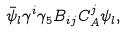<formula> <loc_0><loc_0><loc_500><loc_500>\text { } \bar { \psi } _ { l } \gamma ^ { i } \gamma _ { 5 } B _ { i j } C _ { A } ^ { j } \psi _ { l } ,</formula> 